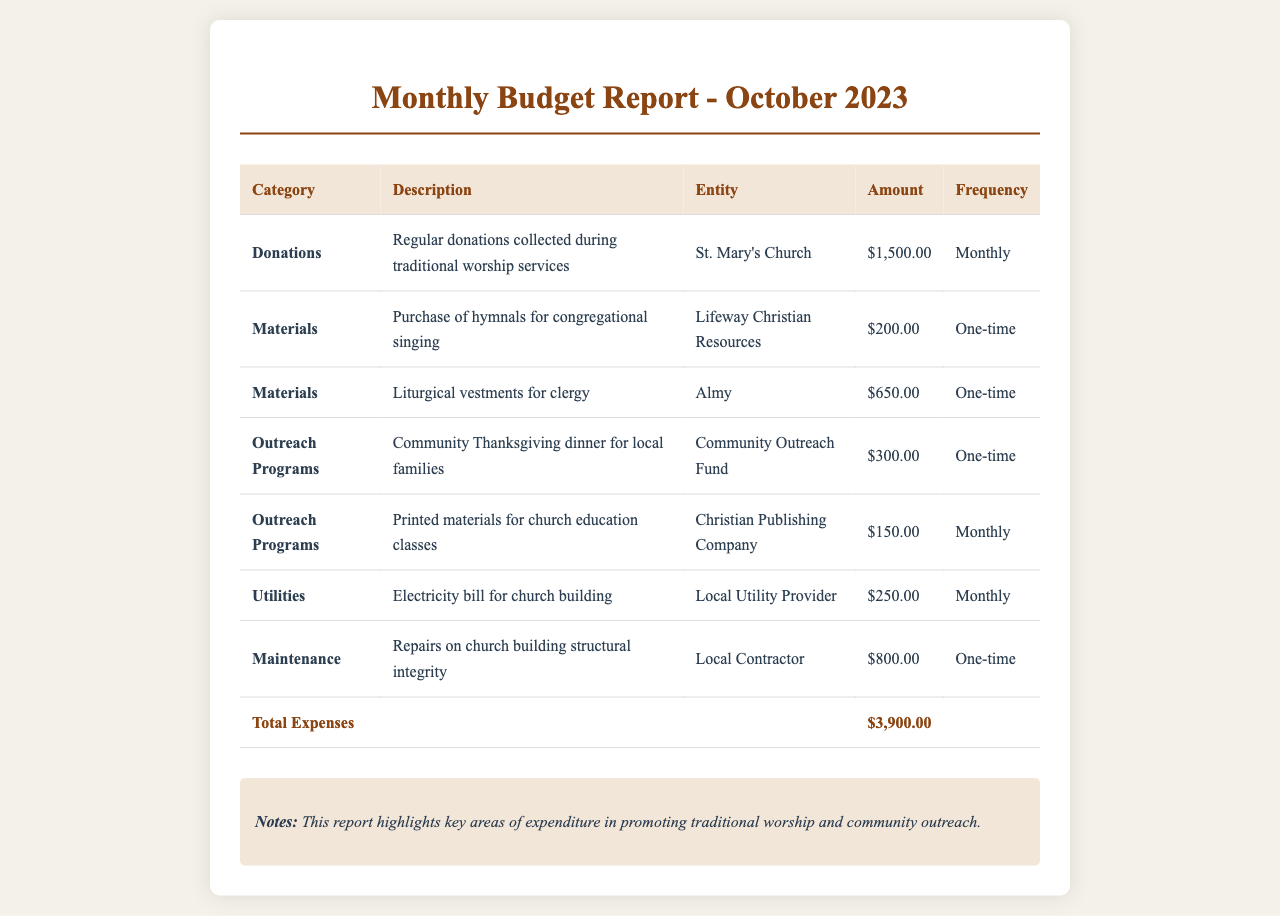What is the total amount of donations collected? The total amount of donations collected is explicitly stated in the document as $1,500.00.
Answer: $1,500.00 How much was spent on liturgical vestments? The expense for liturgical vestments is listed in the document, showing a one-time cost of $650.00.
Answer: $650.00 What is the frequency of printed materials for church education classes? The document specifies that printed materials for church education classes are an ongoing monthly expense.
Answer: Monthly What was the total expense amount for October 2023? The total expenses are summarized at the bottom of the document as $3,900.00.
Answer: $3,900.00 Which entity provided hymnals for congregational singing? The document lists Lifeway Christian Resources as the entity for purchasing hymnals.
Answer: Lifeway Christian Resources What is the purpose of the community Thanksgiving dinner? The document describes the community Thanksgiving dinner as an outreach program for local families.
Answer: Community Thanksgiving dinner How many one-time expenses are listed in the report? There are four one-time expenses indicated throughout the document.
Answer: 4 What is the primary focus mentioned in the notes section? The notes section highlights the focus on promoting traditional worship and community outreach.
Answer: Traditional worship and community outreach 